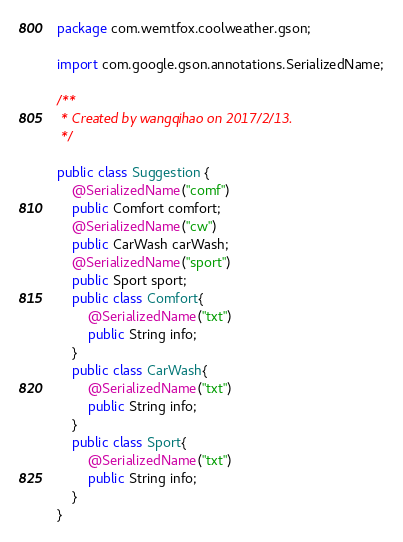<code> <loc_0><loc_0><loc_500><loc_500><_Java_>package com.wemtfox.coolweather.gson;

import com.google.gson.annotations.SerializedName;

/**
 * Created by wangqihao on 2017/2/13.
 */

public class Suggestion {
    @SerializedName("comf")
    public Comfort comfort;
    @SerializedName("cw")
    public CarWash carWash;
    @SerializedName("sport")
    public Sport sport;
    public class Comfort{
        @SerializedName("txt")
        public String info;
    }
    public class CarWash{
        @SerializedName("txt")
        public String info;
    }
    public class Sport{
        @SerializedName("txt")
        public String info;
    }
}
</code> 